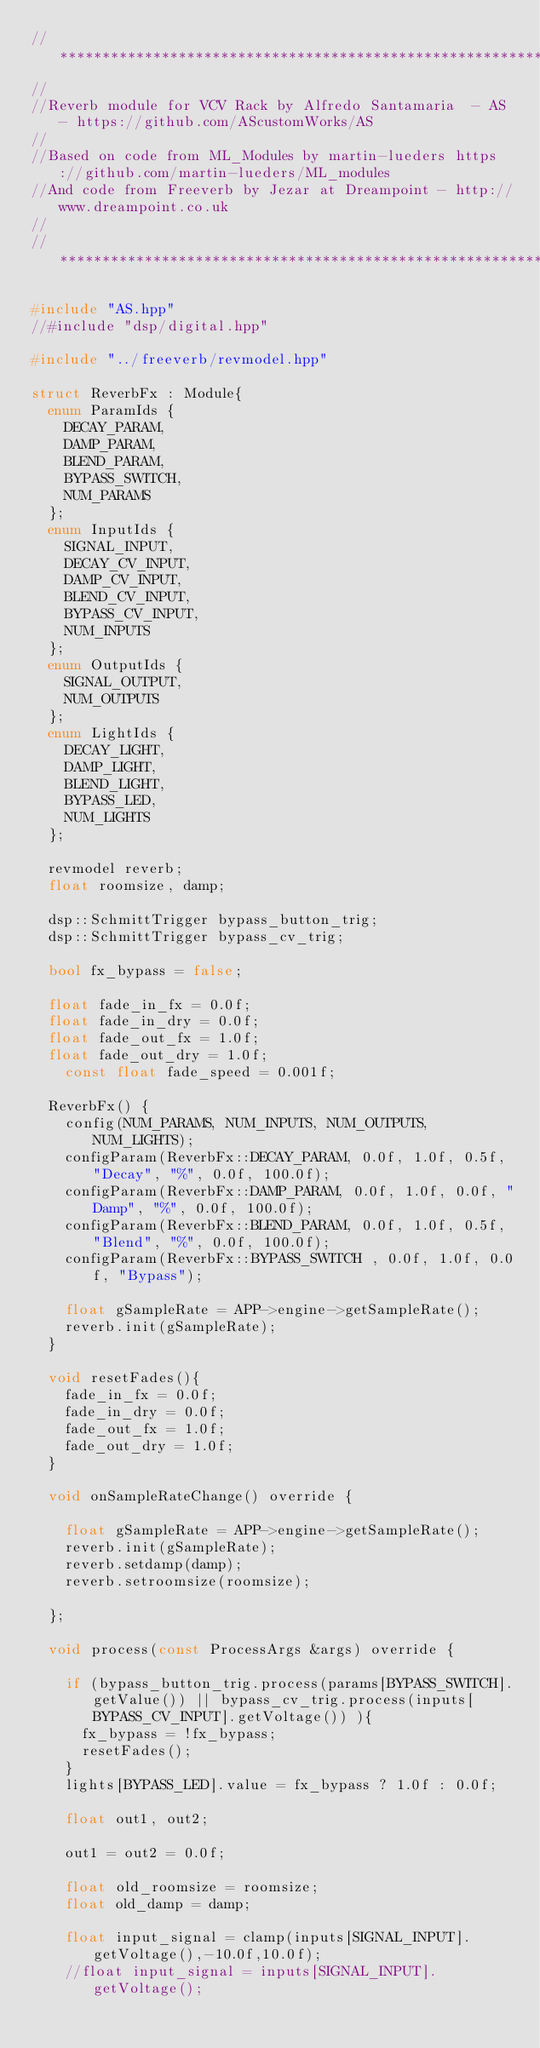Convert code to text. <code><loc_0><loc_0><loc_500><loc_500><_C++_>//***********************************************************************************************
//
//Reverb module for VCV Rack by Alfredo Santamaria  - AS - https://github.com/AScustomWorks/AS
//
//Based on code from ML_Modules by martin-lueders https://github.com/martin-lueders/ML_modules
//And code from Freeverb by Jezar at Dreampoint - http://www.dreampoint.co.uk
//
//***********************************************************************************************

#include "AS.hpp"
//#include "dsp/digital.hpp"

#include "../freeverb/revmodel.hpp"

struct ReverbFx : Module{
	enum ParamIds {
		DECAY_PARAM,
		DAMP_PARAM,
		BLEND_PARAM,
		BYPASS_SWITCH,
		NUM_PARAMS
	};
	enum InputIds {
		SIGNAL_INPUT,
		DECAY_CV_INPUT,
		DAMP_CV_INPUT,
		BLEND_CV_INPUT,
		BYPASS_CV_INPUT,
		NUM_INPUTS
	};
	enum OutputIds {
		SIGNAL_OUTPUT,
		NUM_OUTPUTS
	};
	enum LightIds {
		DECAY_LIGHT,
		DAMP_LIGHT,
		BLEND_LIGHT,
		BYPASS_LED,
		NUM_LIGHTS
	};

	revmodel reverb;
	float roomsize, damp; 

	dsp::SchmittTrigger bypass_button_trig;
	dsp::SchmittTrigger bypass_cv_trig;

	bool fx_bypass = false;

	float fade_in_fx = 0.0f;
	float fade_in_dry = 0.0f;
	float fade_out_fx = 1.0f;
	float fade_out_dry = 1.0f;
    const float fade_speed = 0.001f;

	ReverbFx() {
		config(NUM_PARAMS, NUM_INPUTS, NUM_OUTPUTS, NUM_LIGHTS);
		configParam(ReverbFx::DECAY_PARAM, 0.0f, 1.0f, 0.5f, "Decay", "%", 0.0f, 100.0f);
		configParam(ReverbFx::DAMP_PARAM, 0.0f, 1.0f, 0.0f, "Damp", "%", 0.0f, 100.0f);
		configParam(ReverbFx::BLEND_PARAM, 0.0f, 1.0f, 0.5f, "Blend", "%", 0.0f, 100.0f);
		configParam(ReverbFx::BYPASS_SWITCH , 0.0f, 1.0f, 0.0f, "Bypass");

		float gSampleRate = APP->engine->getSampleRate();
		reverb.init(gSampleRate);
	}

	void resetFades(){
		fade_in_fx = 0.0f;
		fade_in_dry = 0.0f;
		fade_out_fx = 1.0f;
		fade_out_dry = 1.0f;
	}

	void onSampleRateChange() override {

		float gSampleRate = APP->engine->getSampleRate();
		reverb.init(gSampleRate);
		reverb.setdamp(damp);
		reverb.setroomsize(roomsize);

	};

	void process(const ProcessArgs &args) override {

		if (bypass_button_trig.process(params[BYPASS_SWITCH].getValue()) || bypass_cv_trig.process(inputs[BYPASS_CV_INPUT].getVoltage()) ){
			fx_bypass = !fx_bypass;
			resetFades();
		}
		lights[BYPASS_LED].value = fx_bypass ? 1.0f : 0.0f;

		float out1, out2;

		out1 = out2 = 0.0f;

		float old_roomsize = roomsize;
		float old_damp = damp;

		float input_signal = clamp(inputs[SIGNAL_INPUT].getVoltage(),-10.0f,10.0f);
		//float input_signal = inputs[SIGNAL_INPUT].getVoltage();
		</code> 